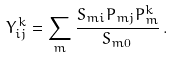<formula> <loc_0><loc_0><loc_500><loc_500>Y _ { i j } ^ { \, k } = \sum _ { m } \frac { S _ { m i } P _ { m j } P _ { m } ^ { k } } { S _ { m 0 } } \, .</formula> 